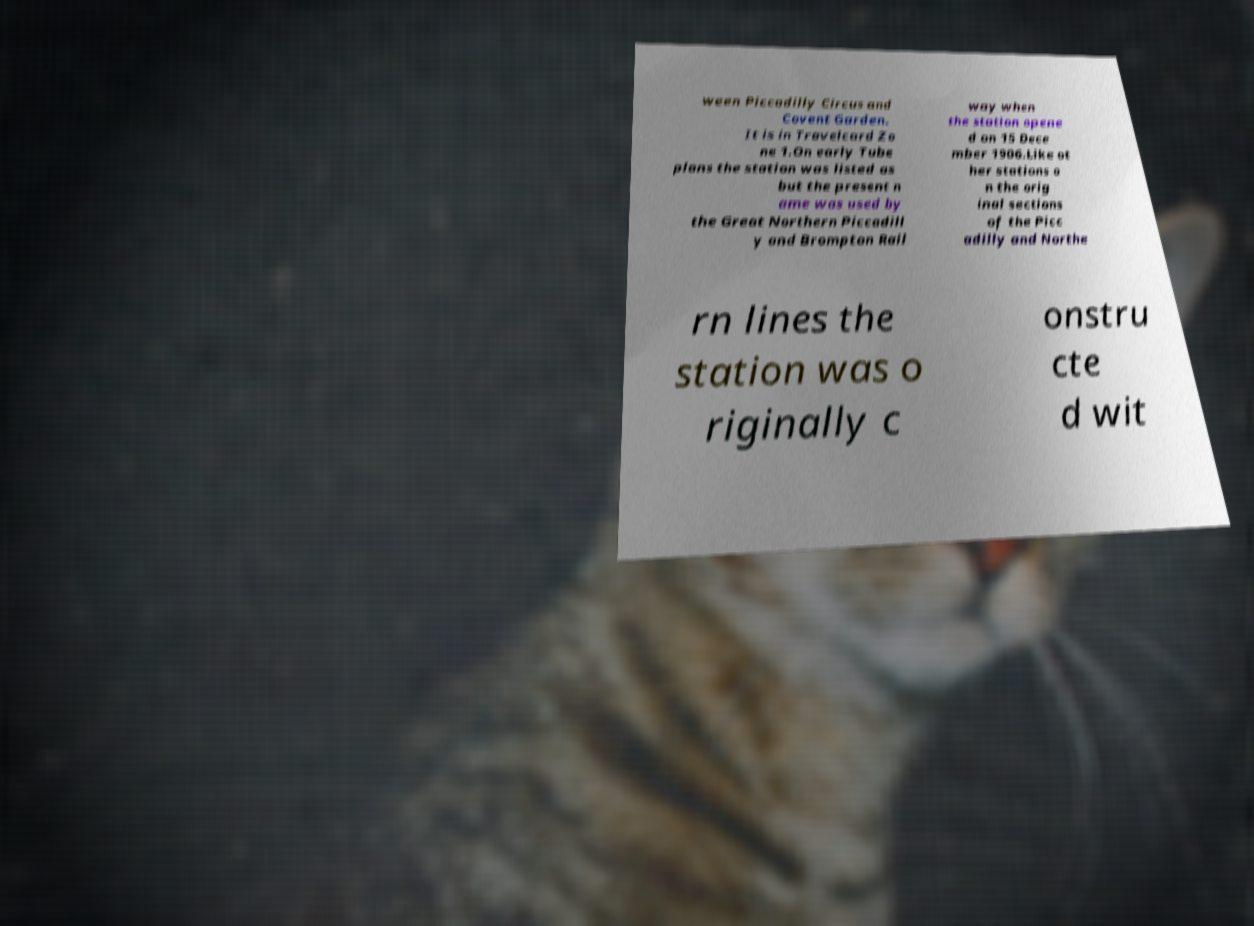Could you assist in decoding the text presented in this image and type it out clearly? ween Piccadilly Circus and Covent Garden. It is in Travelcard Zo ne 1.On early Tube plans the station was listed as but the present n ame was used by the Great Northern Piccadill y and Brompton Rail way when the station opene d on 15 Dece mber 1906.Like ot her stations o n the orig inal sections of the Picc adilly and Northe rn lines the station was o riginally c onstru cte d wit 